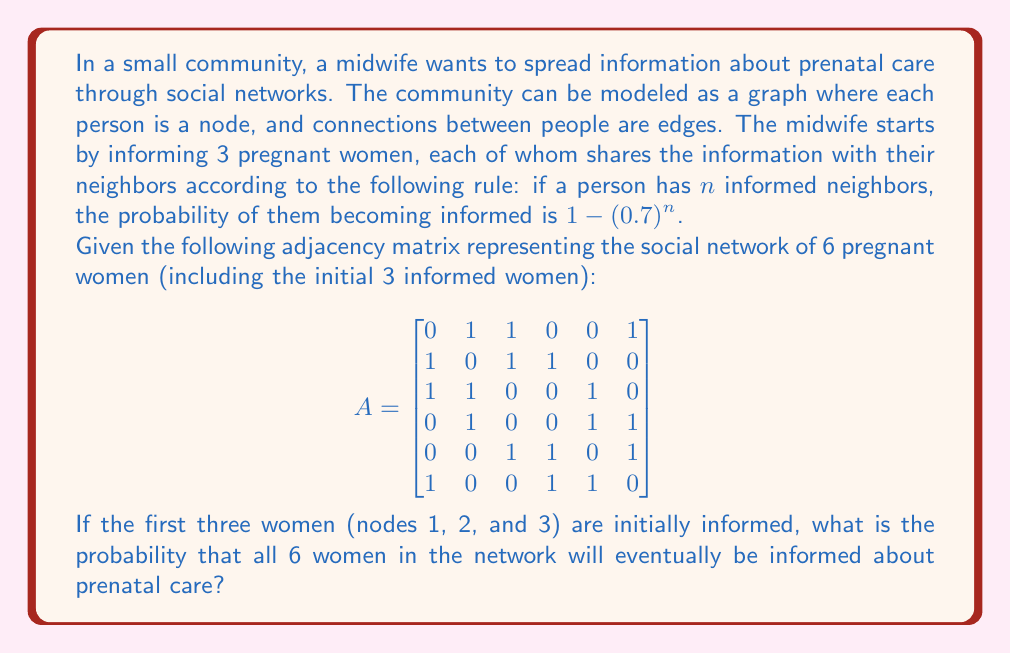What is the answer to this math problem? Let's approach this step-by-step:

1) First, we need to identify which women are connected to the initially informed women (1, 2, and 3).

   - Woman 4 is connected to woman 2
   - Woman 5 is connected to woman 3
   - Woman 6 is connected to woman 1

2) Now, let's calculate the probability of each uninformed woman becoming informed:

   - For woman 4: She has 1 informed neighbor, so her probability is $1 - (0.7)^1 = 0.3$
   - For woman 5: She has 1 informed neighbor, so her probability is $1 - (0.7)^1 = 0.3$
   - For woman 6: She has 1 informed neighbor, so her probability is $1 - (0.7)^1 = 0.3$

3) The probability of all three becoming informed is the product of their individual probabilities:

   $P(\text{all becoming informed}) = 0.3 \times 0.3 \times 0.3 = 0.027$

4) However, we need to consider all possible scenarios where the information spreads to all 6 women. This includes cases where some women become informed in later stages.

5) Let's consider the other possible scenarios:

   a) If only two of the uninformed women become informed in the first stage:
      - Woman 4 and 5: $0.3 \times 0.3 \times 0.7 \times [1-(0.7)^3] = 0.04116$
      - Woman 4 and 6: $0.3 \times 0.7 \times 0.3 \times [1-(0.7)^3] = 0.04116$
      - Woman 5 and 6: $0.7 \times 0.3 \times 0.3 \times [1-(0.7)^3] = 0.04116$

   b) If only one of the uninformed women becomes informed in the first stage:
      - Only Woman 4: $0.3 \times 0.7 \times 0.7 \times [1-(0.7)^2]^2 = 0.024696$
      - Only Woman 5: $0.7 \times 0.3 \times 0.7 \times [1-(0.7)^2]^2 = 0.024696$
      - Only Woman 6: $0.7 \times 0.7 \times 0.3 \times [1-(0.7)^2]^2 = 0.024696$

6) The total probability is the sum of all these scenarios:

   $P(\text{total}) = 0.027 + 0.04116 + 0.04116 + 0.04116 + 0.024696 + 0.024696 + 0.024696 = 0.224568$

Therefore, the probability that all 6 women in the network will eventually be informed about prenatal care is approximately 0.224568 or 22.46%.
Answer: 0.224568 or 22.46% 